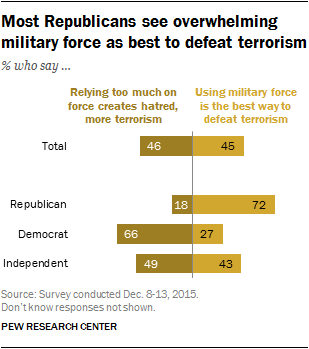Indicate a few pertinent items in this graphic. What is the total amount of the largest brown bar and the median yellow bar? A recent survey found that 27% of Democrats believe that using military force is the most effective way to combat terrorism. 